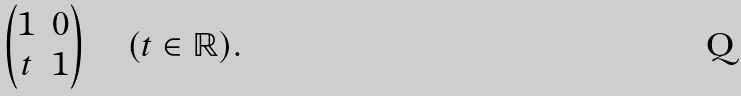Convert formula to latex. <formula><loc_0><loc_0><loc_500><loc_500>\left ( \begin{matrix} 1 & 0 \\ t & 1 \\ \end{matrix} \right ) \quad ( t \in \mathbb { R } ) .</formula> 